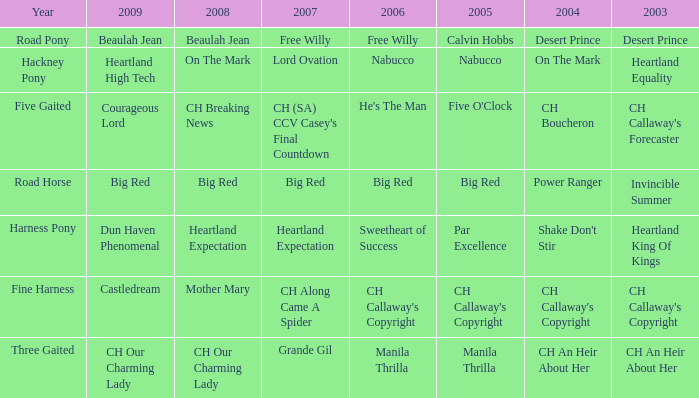Can you parse all the data within this table? {'header': ['Year', '2009', '2008', '2007', '2006', '2005', '2004', '2003'], 'rows': [['Road Pony', 'Beaulah Jean', 'Beaulah Jean', 'Free Willy', 'Free Willy', 'Calvin Hobbs', 'Desert Prince', 'Desert Prince'], ['Hackney Pony', 'Heartland High Tech', 'On The Mark', 'Lord Ovation', 'Nabucco', 'Nabucco', 'On The Mark', 'Heartland Equality'], ['Five Gaited', 'Courageous Lord', 'CH Breaking News', "CH (SA) CCV Casey's Final Countdown", "He's The Man", "Five O'Clock", 'CH Boucheron', "CH Callaway's Forecaster"], ['Road Horse', 'Big Red', 'Big Red', 'Big Red', 'Big Red', 'Big Red', 'Power Ranger', 'Invincible Summer'], ['Harness Pony', 'Dun Haven Phenomenal', 'Heartland Expectation', 'Heartland Expectation', 'Sweetheart of Success', 'Par Excellence', "Shake Don't Stir", 'Heartland King Of Kings'], ['Fine Harness', 'Castledream', 'Mother Mary', 'CH Along Came A Spider', "CH Callaway's Copyright", "CH Callaway's Copyright", "CH Callaway's Copyright", "CH Callaway's Copyright"], ['Three Gaited', 'CH Our Charming Lady', 'CH Our Charming Lady', 'Grande Gil', 'Manila Thrilla', 'Manila Thrilla', 'CH An Heir About Her', 'CH An Heir About Her']]} What is the 2008 for 2009 heartland high tech? On The Mark. 